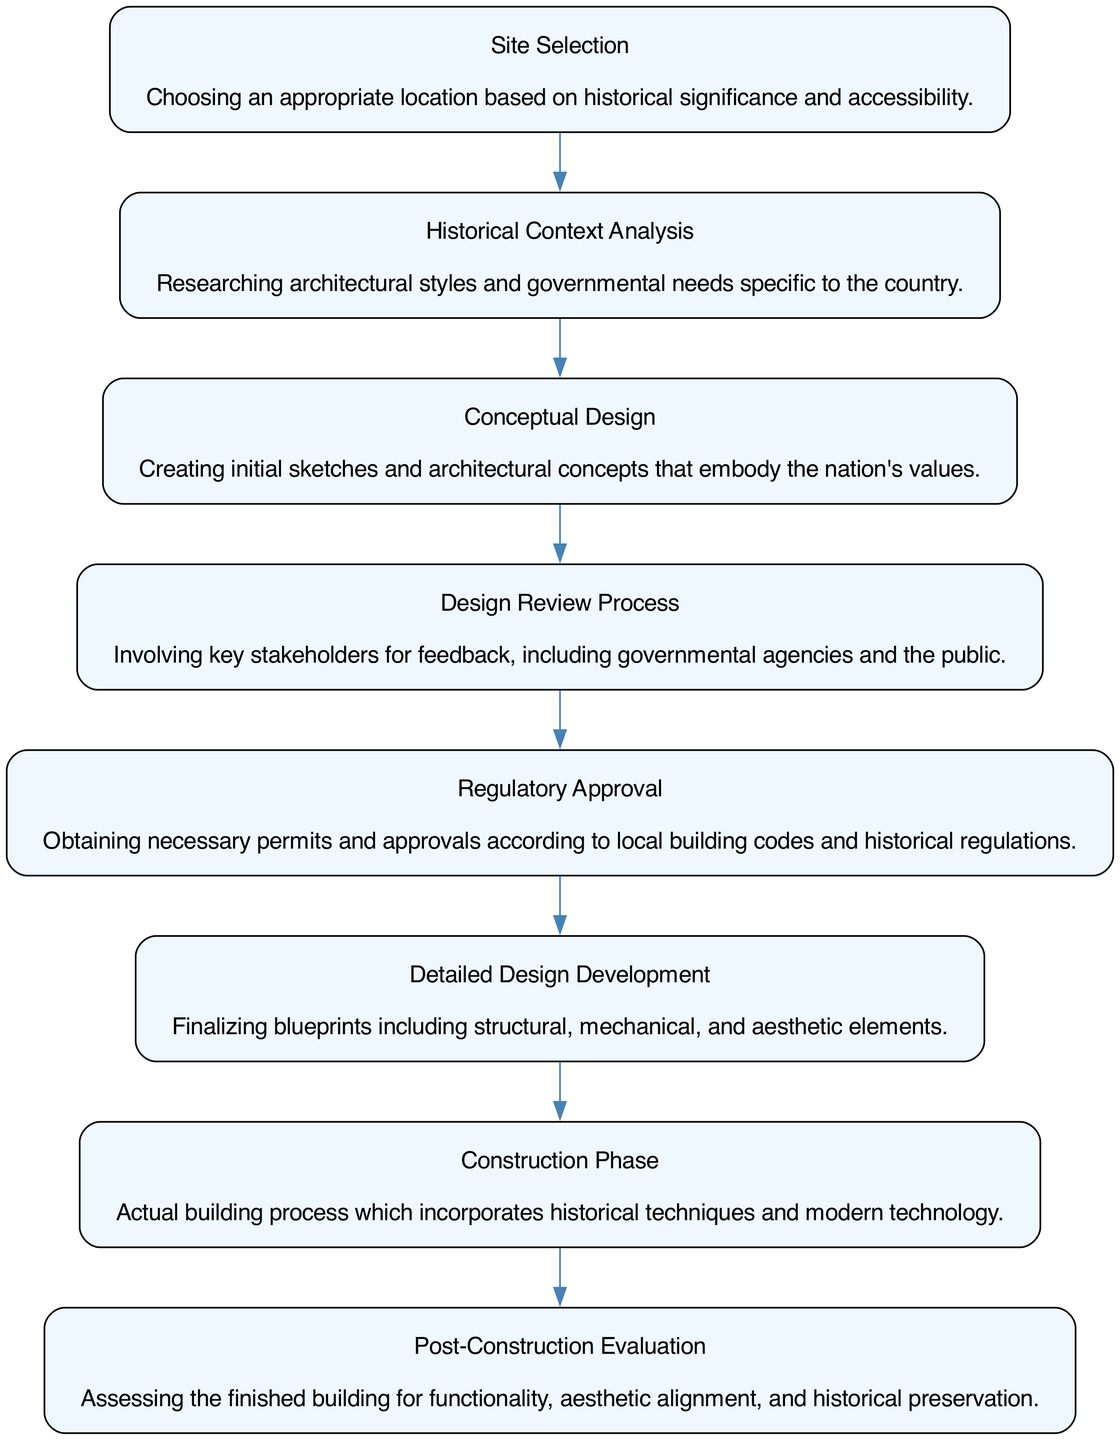What is the first stage in the diagram? The first stage in the diagram is "Site Selection," as it is the initial step in the flow of architectural design elements.
Answer: Site Selection How many stages are there in total? Counting the stages listed in the diagram, there are eight distinct stages that represent the flow of architectural design elements.
Answer: 8 What does the second stage focus on? The second stage focuses on "Historical Context Analysis," which involves researching architectural styles and governmental needs specific to the country.
Answer: Historical Context Analysis Which stage directly follows the "Conceptual Design" stage? The stage that follows "Conceptual Design" is "Design Review Process," indicating that feedback from stakeholders comes after conceptualizing designs.
Answer: Design Review Process What is the last stage before the final evaluation of the building? The stage before the "Post-Construction Evaluation" is the "Construction Phase," highlighting the transition from building to evaluating the completed structure.
Answer: Construction Phase How does "Regulatory Approval" relate to "Detailed Design Development"? "Regulatory Approval" occurs before "Detailed Design Development," suggesting that obtaining necessary permits is essential prior to finalizing the blueprints.
Answer: Before What aspect does "Post-Construction Evaluation" primarily assess? "Post-Construction Evaluation" primarily assesses the finished building for its functionality, aesthetic alignment, and historical preservation, ensuring it meets all required standards.
Answer: Functionality, aesthetic alignment, and historical preservation Which stage emphasizes stakeholder feedback? The "Design Review Process" emphasizes stakeholder feedback, as it involves input from governmental agencies and the public about the architectural design.
Answer: Design Review Process What are the components included in "Detailed Design Development"? "Detailed Design Development" includes finalizing blueprints that incorporate structural, mechanical, and aesthetic elements, focusing on all aspects of the building design.
Answer: Structural, mechanical, and aesthetic elements 